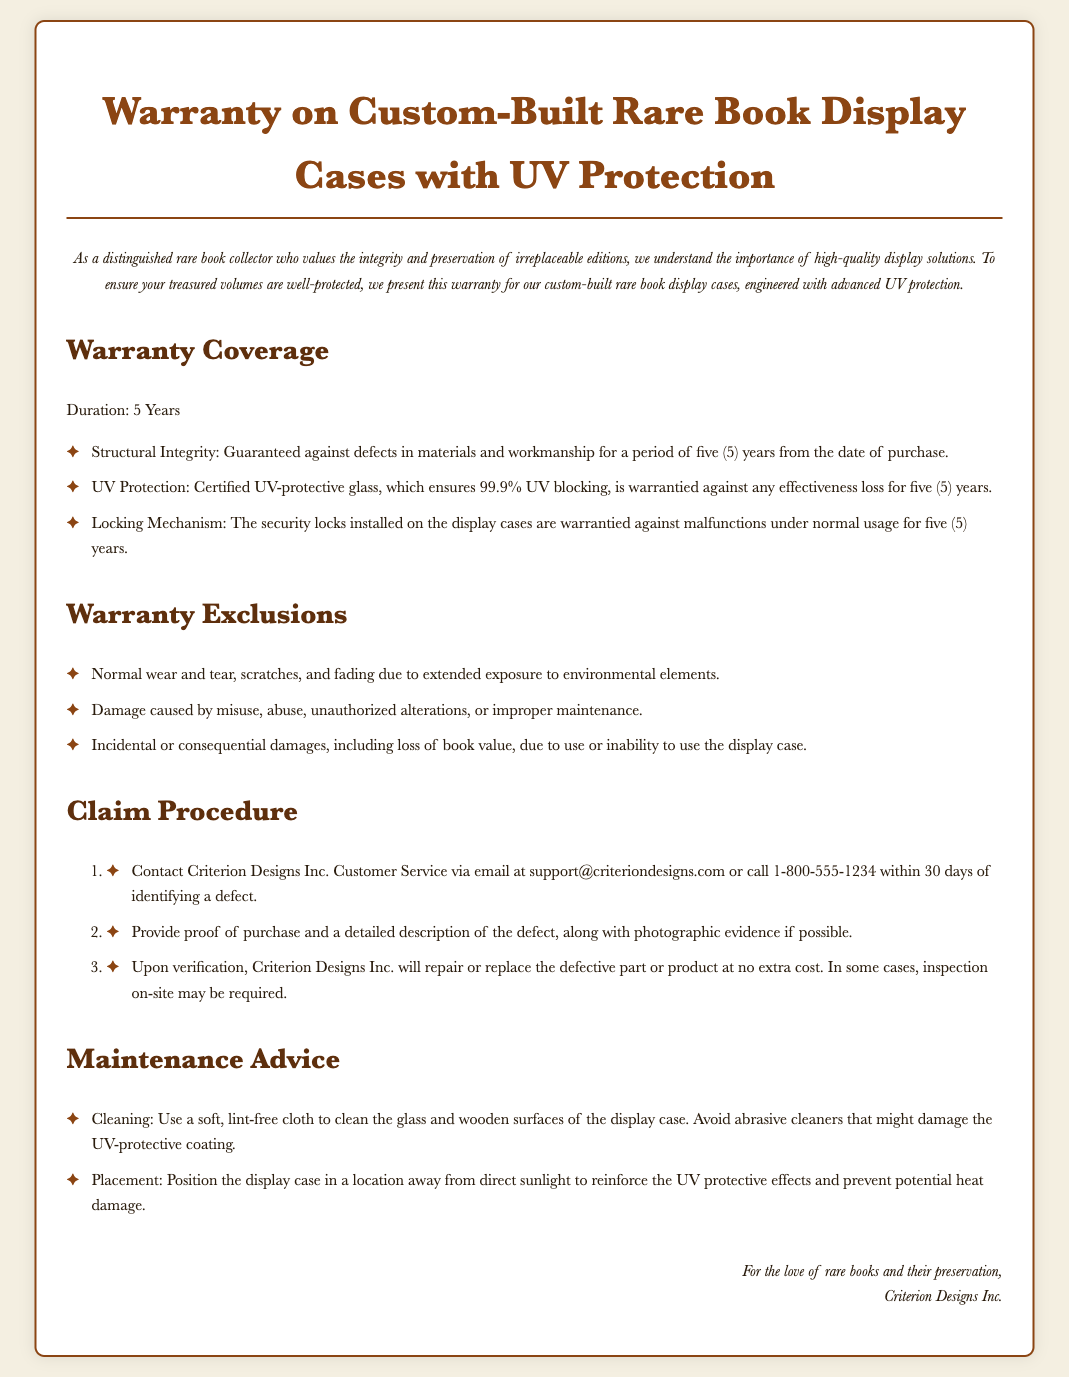What is the duration of the warranty? The warranty duration for the display cases is specified in the document as five years.
Answer: 5 Years What percentage of UV protection does the glass provide? The document states that the glass ensures 99.9% UV blocking as part of the warranty.
Answer: 99.9% What type of damage is excluded under the warranty? The document mentions that normal wear and tear is one of the exclusions from the warranty coverage.
Answer: Normal wear and tear What should you do within 30 days of identifying a defect? The claim procedure outlines that a contact with customer service should be made within 30 days of identifying a defect.
Answer: Contact customer service Who is the manufacturer of the display cases? The signature at the bottom of the document indicates that Criterion Designs Inc. is the manufacturer.
Answer: Criterion Designs Inc What cleaning method is recommended for the display case? The maintenance advice section specifies that a soft, lint-free cloth should be used to clean the surfaces.
Answer: Soft, lint-free cloth What happens upon verification of a defect? According to the claim procedure, if a defect is verified, the manufacturer will repair or replace the defective part.
Answer: Repair or replace What contact method is provided for customer service? The document provides an email address and a phone number as contact methods for customer service.
Answer: Email or call What specific locking feature is covered under the warranty? The warranty highlights that the security locks installed are warrantied against malfunctions under normal usage.
Answer: Locking Mechanism 